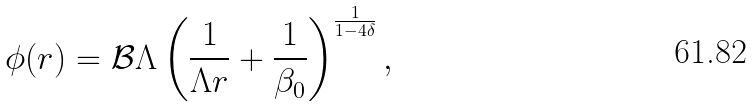<formula> <loc_0><loc_0><loc_500><loc_500>\phi ( r ) = \mathcal { B } \Lambda \left ( \frac { 1 } { \Lambda r } + \frac { 1 } { \beta _ { 0 } } \right ) ^ { \frac { 1 } { 1 - 4 \delta } } ,</formula> 